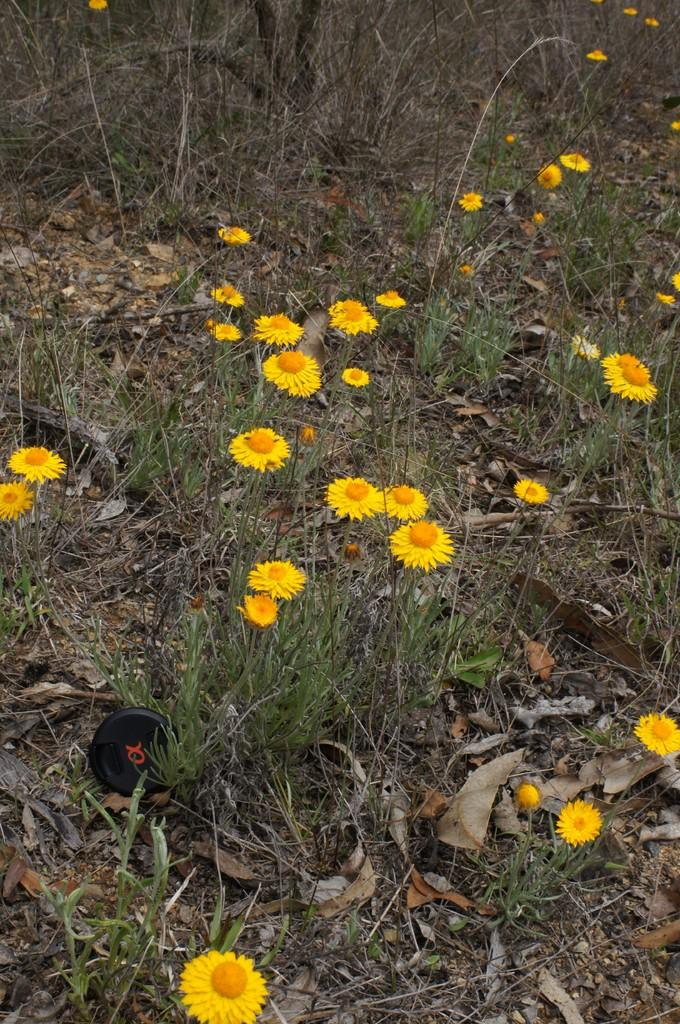Where was the image taken? The image is taken outdoors. What type of surface is visible in the image? There is a ground with grass in the image. What can be found on the ground in the image? Dry leaves are present on the ground. What type of flora is visible in the image? There are yellow flowers in the image. What type of quartz can be seen in the image? There is no quartz present in the image. What kind of structure is visible in the background of the image? There is no structure visible in the image; it is taken outdoors with a focus on the ground and flora. 